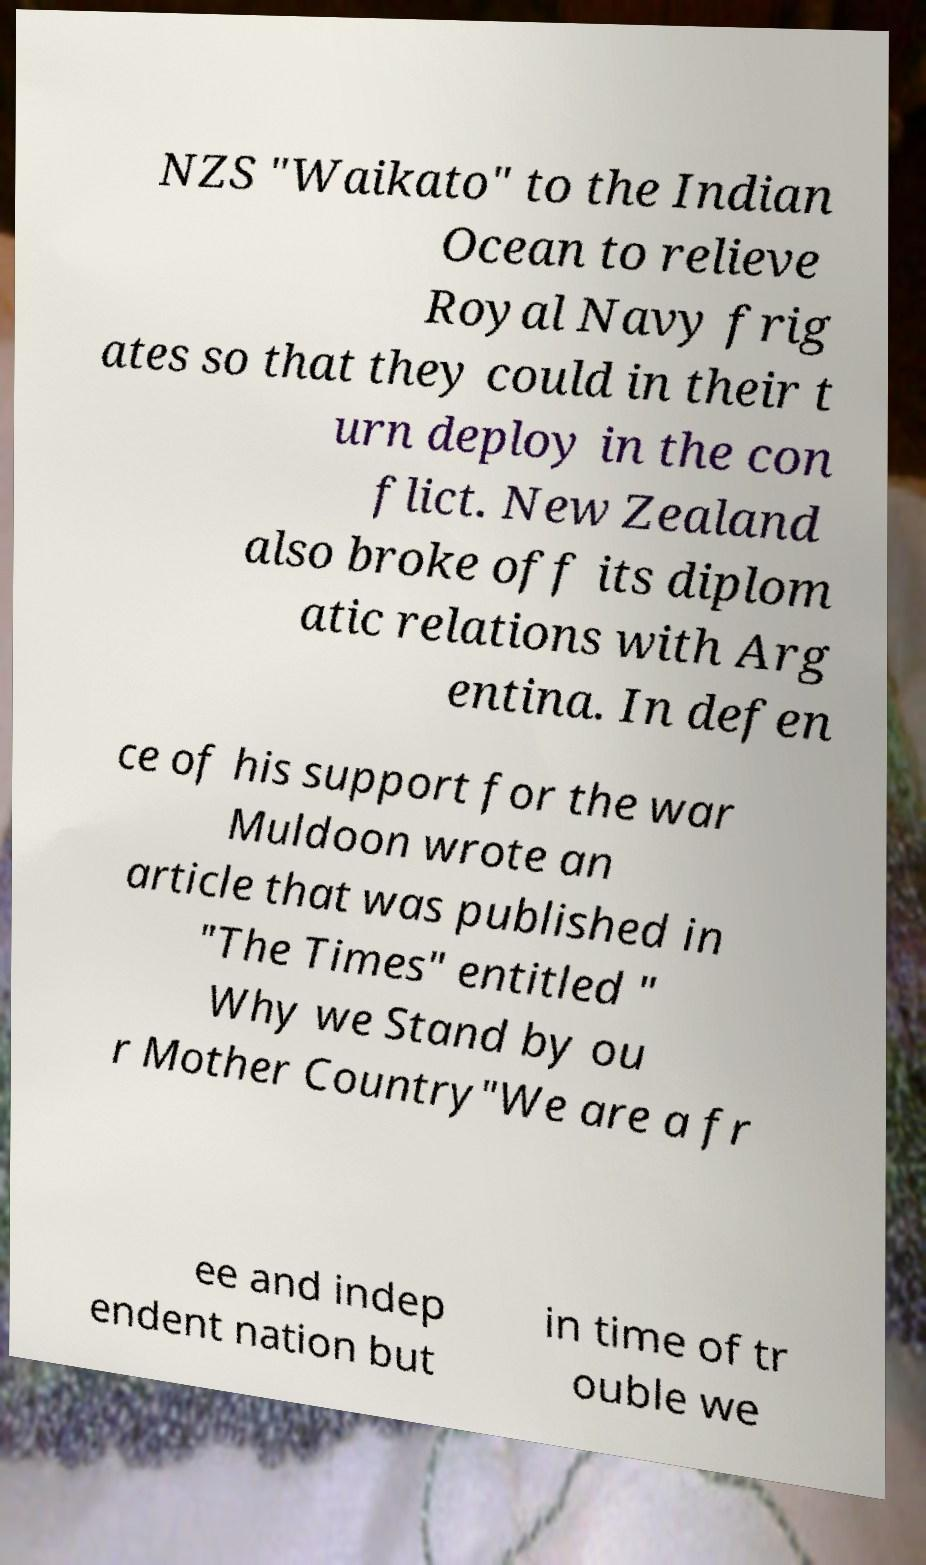There's text embedded in this image that I need extracted. Can you transcribe it verbatim? NZS "Waikato" to the Indian Ocean to relieve Royal Navy frig ates so that they could in their t urn deploy in the con flict. New Zealand also broke off its diplom atic relations with Arg entina. In defen ce of his support for the war Muldoon wrote an article that was published in "The Times" entitled " Why we Stand by ou r Mother Country"We are a fr ee and indep endent nation but in time of tr ouble we 